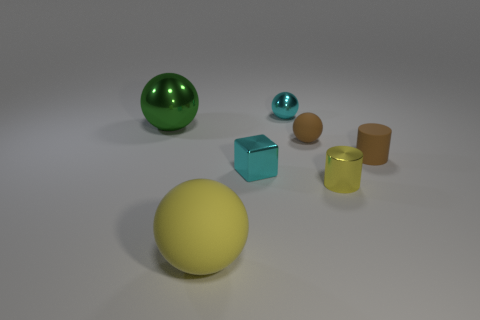Is the color of the rubber cylinder the same as the small matte ball? While both the rubber cylinder and the small matte ball share a similarity in color hue, referring to a kind of green, they are not exactly the same. The cylinder appears to have a more yellowish-green color, whereas the small matte ball exhibits a bluish-green, indicating slight variations in their coloration. 